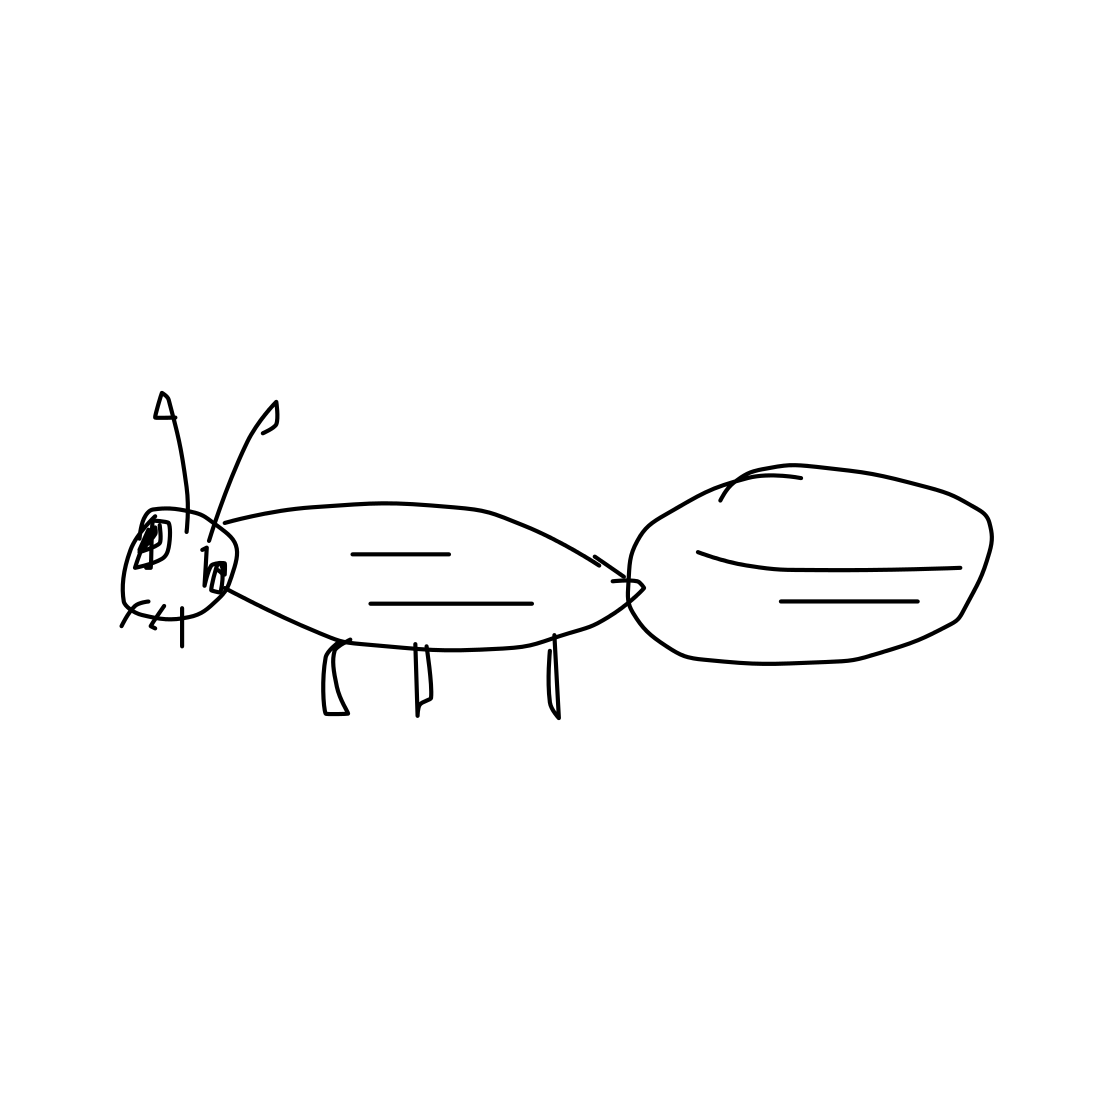In this task, you will identify whether the picture contains a living organism. The images given are black and white sketches drawn by human beings. If the picture depicts a living organism or part of a living organism, the output should be 'Living'. Otherwise, print 'Non-Living'. The image presents a simple yet identifiable sketch of an ant, characterized by its segmented body and six legs, which are typical features of insects. As ants are indeed living organisms, the correct classification for this image according to the task's guidelines is 'Living'. This sketch not only depicts the basic form of an ant but also subtly captures essential biological features, making it a clear representation of a living entity. 